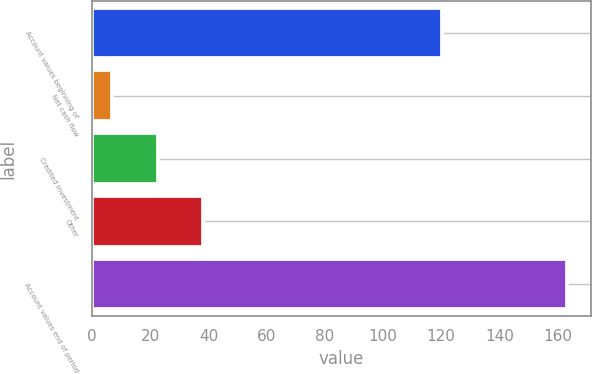Convert chart to OTSL. <chart><loc_0><loc_0><loc_500><loc_500><bar_chart><fcel>Account values beginning of<fcel>Net cash flow<fcel>Credited investment<fcel>Other<fcel>Account values end of period<nl><fcel>120.3<fcel>6.9<fcel>22.54<fcel>38.18<fcel>163.3<nl></chart> 